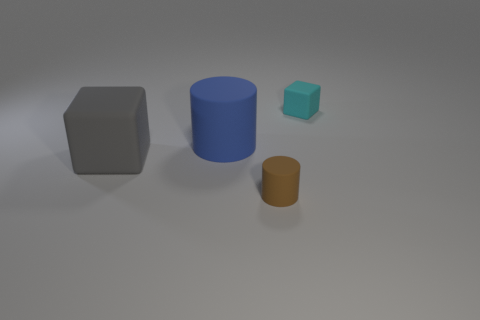There is a brown matte thing; what shape is it?
Offer a very short reply. Cylinder. Is the number of matte cylinders to the right of the large cube greater than the number of blue rubber cylinders behind the small cube?
Make the answer very short. Yes. How many other objects are the same size as the brown object?
Give a very brief answer. 1. There is a object that is in front of the large blue rubber thing and to the left of the small matte cylinder; what material is it?
Offer a very short reply. Rubber. What number of cylinders are on the right side of the matte object that is on the right side of the tiny object that is left of the small cyan object?
Offer a terse response. 0. Is there any other thing of the same color as the small rubber cylinder?
Provide a succinct answer. No. What number of matte things are both right of the blue matte cylinder and behind the gray rubber block?
Provide a succinct answer. 1. There is a block on the left side of the big blue matte cylinder; does it have the same size as the rubber block behind the big gray cube?
Provide a succinct answer. No. How many objects are objects that are in front of the cyan matte thing or blue things?
Your response must be concise. 3. What is the cube that is left of the small block made of?
Provide a succinct answer. Rubber. 